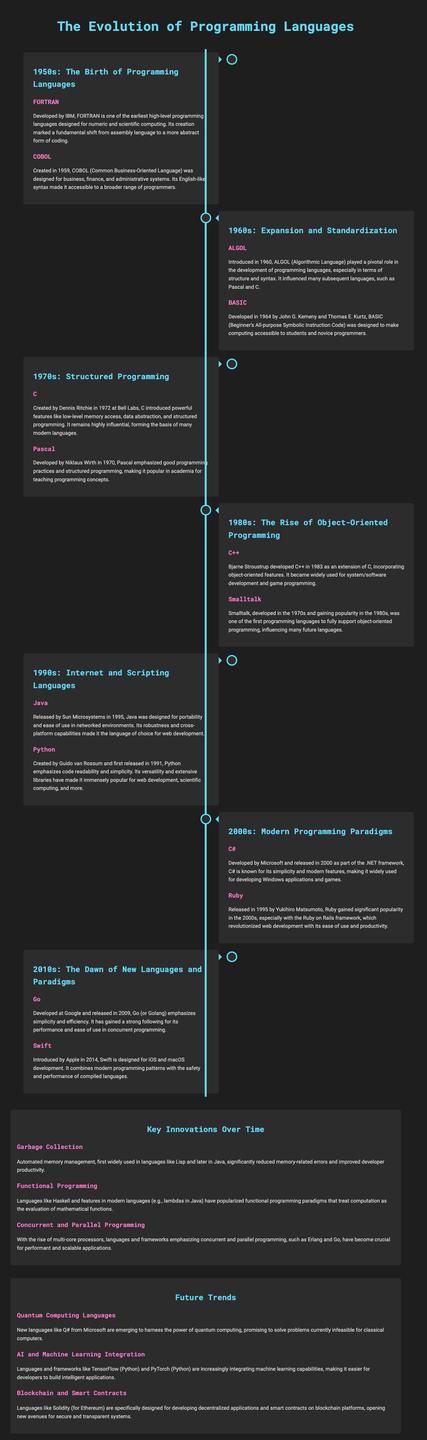What programming language was developed by IBM in the 1950s? The document states that FORTRAN was developed by IBM in the 1950s.
Answer: FORTRAN Who created the BASIC programming language? According to the document, BASIC was developed by John G. Kemeny and Thomas E. Kurtz in 1964.
Answer: John G. Kemeny and Thomas E. Kurtz In which decade was C++ developed? The timeline indicates that C++ was developed in the 1980s.
Answer: 1980s What key innovation focuses on automated memory management? The document mentions Garbage Collection as a key innovation regarding automated memory management.
Answer: Garbage Collection Which programming language was first released in 1991? The document states that Python was first released in 1991.
Answer: Python Which programming language emphasizes simplicity and efficiency and was released in 2009? The infographic states that Go emphasizes simplicity and efficiency and was developed in 2009.
Answer: Go What is the primary purpose of COBOL? The document explains that COBOL was designed for business, finance, and administrative systems.
Answer: Business, finance, and administrative systems Which innovation popularizes the evaluation of mathematical functions? The document describes Functional Programming as the innovation that popularizes this evaluation.
Answer: Functional Programming What emerging language is mentioned for quantum computing? The document highlights Q# as the emerging language for quantum computing.
Answer: Q# 